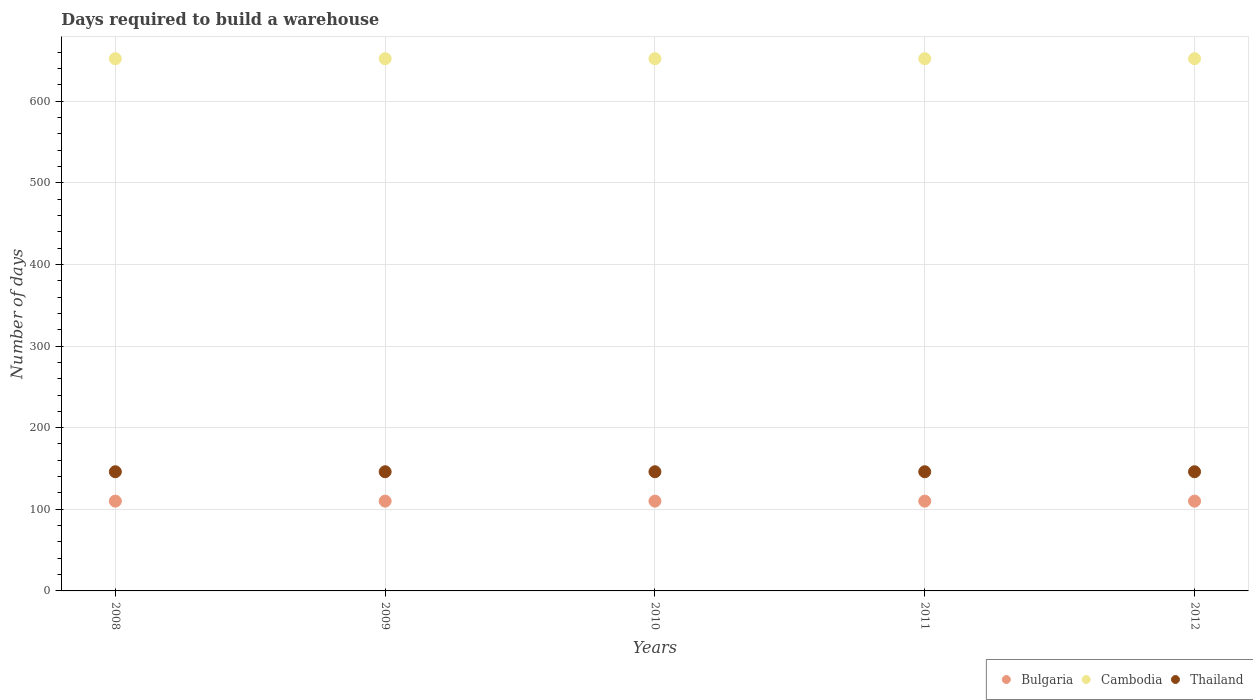What is the days required to build a warehouse in in Thailand in 2009?
Give a very brief answer. 146. Across all years, what is the maximum days required to build a warehouse in in Cambodia?
Your response must be concise. 652. Across all years, what is the minimum days required to build a warehouse in in Cambodia?
Offer a terse response. 652. In which year was the days required to build a warehouse in in Thailand minimum?
Provide a succinct answer. 2008. What is the total days required to build a warehouse in in Thailand in the graph?
Ensure brevity in your answer.  730. What is the difference between the days required to build a warehouse in in Bulgaria in 2011 and the days required to build a warehouse in in Cambodia in 2009?
Provide a short and direct response. -542. What is the average days required to build a warehouse in in Bulgaria per year?
Give a very brief answer. 110. In the year 2012, what is the difference between the days required to build a warehouse in in Bulgaria and days required to build a warehouse in in Thailand?
Provide a succinct answer. -36. In how many years, is the days required to build a warehouse in in Bulgaria greater than 580 days?
Your response must be concise. 0. Does the graph contain any zero values?
Provide a succinct answer. No. What is the title of the graph?
Offer a terse response. Days required to build a warehouse. What is the label or title of the Y-axis?
Provide a succinct answer. Number of days. What is the Number of days in Bulgaria in 2008?
Your answer should be compact. 110. What is the Number of days of Cambodia in 2008?
Your answer should be very brief. 652. What is the Number of days of Thailand in 2008?
Your answer should be compact. 146. What is the Number of days of Bulgaria in 2009?
Your response must be concise. 110. What is the Number of days of Cambodia in 2009?
Keep it short and to the point. 652. What is the Number of days in Thailand in 2009?
Your response must be concise. 146. What is the Number of days of Bulgaria in 2010?
Your answer should be very brief. 110. What is the Number of days of Cambodia in 2010?
Keep it short and to the point. 652. What is the Number of days in Thailand in 2010?
Give a very brief answer. 146. What is the Number of days in Bulgaria in 2011?
Offer a terse response. 110. What is the Number of days in Cambodia in 2011?
Ensure brevity in your answer.  652. What is the Number of days of Thailand in 2011?
Provide a succinct answer. 146. What is the Number of days in Bulgaria in 2012?
Provide a succinct answer. 110. What is the Number of days in Cambodia in 2012?
Give a very brief answer. 652. What is the Number of days of Thailand in 2012?
Give a very brief answer. 146. Across all years, what is the maximum Number of days of Bulgaria?
Provide a succinct answer. 110. Across all years, what is the maximum Number of days in Cambodia?
Your answer should be very brief. 652. Across all years, what is the maximum Number of days of Thailand?
Offer a terse response. 146. Across all years, what is the minimum Number of days of Bulgaria?
Provide a short and direct response. 110. Across all years, what is the minimum Number of days of Cambodia?
Provide a short and direct response. 652. Across all years, what is the minimum Number of days of Thailand?
Provide a short and direct response. 146. What is the total Number of days of Bulgaria in the graph?
Your response must be concise. 550. What is the total Number of days in Cambodia in the graph?
Your answer should be compact. 3260. What is the total Number of days in Thailand in the graph?
Give a very brief answer. 730. What is the difference between the Number of days in Cambodia in 2008 and that in 2009?
Your answer should be very brief. 0. What is the difference between the Number of days in Thailand in 2008 and that in 2009?
Offer a very short reply. 0. What is the difference between the Number of days of Thailand in 2008 and that in 2010?
Provide a succinct answer. 0. What is the difference between the Number of days of Bulgaria in 2008 and that in 2011?
Your response must be concise. 0. What is the difference between the Number of days in Thailand in 2008 and that in 2011?
Provide a short and direct response. 0. What is the difference between the Number of days in Bulgaria in 2008 and that in 2012?
Provide a succinct answer. 0. What is the difference between the Number of days of Cambodia in 2008 and that in 2012?
Provide a short and direct response. 0. What is the difference between the Number of days in Thailand in 2008 and that in 2012?
Ensure brevity in your answer.  0. What is the difference between the Number of days of Bulgaria in 2009 and that in 2010?
Offer a very short reply. 0. What is the difference between the Number of days of Cambodia in 2009 and that in 2010?
Ensure brevity in your answer.  0. What is the difference between the Number of days in Thailand in 2009 and that in 2010?
Offer a terse response. 0. What is the difference between the Number of days in Bulgaria in 2009 and that in 2011?
Make the answer very short. 0. What is the difference between the Number of days in Bulgaria in 2009 and that in 2012?
Make the answer very short. 0. What is the difference between the Number of days in Bulgaria in 2010 and that in 2011?
Give a very brief answer. 0. What is the difference between the Number of days in Thailand in 2010 and that in 2011?
Offer a terse response. 0. What is the difference between the Number of days in Thailand in 2010 and that in 2012?
Keep it short and to the point. 0. What is the difference between the Number of days in Cambodia in 2011 and that in 2012?
Offer a very short reply. 0. What is the difference between the Number of days in Thailand in 2011 and that in 2012?
Offer a very short reply. 0. What is the difference between the Number of days of Bulgaria in 2008 and the Number of days of Cambodia in 2009?
Offer a terse response. -542. What is the difference between the Number of days in Bulgaria in 2008 and the Number of days in Thailand in 2009?
Give a very brief answer. -36. What is the difference between the Number of days of Cambodia in 2008 and the Number of days of Thailand in 2009?
Your response must be concise. 506. What is the difference between the Number of days in Bulgaria in 2008 and the Number of days in Cambodia in 2010?
Keep it short and to the point. -542. What is the difference between the Number of days in Bulgaria in 2008 and the Number of days in Thailand in 2010?
Ensure brevity in your answer.  -36. What is the difference between the Number of days in Cambodia in 2008 and the Number of days in Thailand in 2010?
Your response must be concise. 506. What is the difference between the Number of days of Bulgaria in 2008 and the Number of days of Cambodia in 2011?
Make the answer very short. -542. What is the difference between the Number of days of Bulgaria in 2008 and the Number of days of Thailand in 2011?
Make the answer very short. -36. What is the difference between the Number of days in Cambodia in 2008 and the Number of days in Thailand in 2011?
Your response must be concise. 506. What is the difference between the Number of days in Bulgaria in 2008 and the Number of days in Cambodia in 2012?
Offer a terse response. -542. What is the difference between the Number of days in Bulgaria in 2008 and the Number of days in Thailand in 2012?
Ensure brevity in your answer.  -36. What is the difference between the Number of days of Cambodia in 2008 and the Number of days of Thailand in 2012?
Provide a short and direct response. 506. What is the difference between the Number of days in Bulgaria in 2009 and the Number of days in Cambodia in 2010?
Your answer should be compact. -542. What is the difference between the Number of days of Bulgaria in 2009 and the Number of days of Thailand in 2010?
Ensure brevity in your answer.  -36. What is the difference between the Number of days in Cambodia in 2009 and the Number of days in Thailand in 2010?
Make the answer very short. 506. What is the difference between the Number of days in Bulgaria in 2009 and the Number of days in Cambodia in 2011?
Offer a terse response. -542. What is the difference between the Number of days of Bulgaria in 2009 and the Number of days of Thailand in 2011?
Make the answer very short. -36. What is the difference between the Number of days in Cambodia in 2009 and the Number of days in Thailand in 2011?
Make the answer very short. 506. What is the difference between the Number of days of Bulgaria in 2009 and the Number of days of Cambodia in 2012?
Your answer should be very brief. -542. What is the difference between the Number of days of Bulgaria in 2009 and the Number of days of Thailand in 2012?
Ensure brevity in your answer.  -36. What is the difference between the Number of days of Cambodia in 2009 and the Number of days of Thailand in 2012?
Give a very brief answer. 506. What is the difference between the Number of days in Bulgaria in 2010 and the Number of days in Cambodia in 2011?
Offer a very short reply. -542. What is the difference between the Number of days of Bulgaria in 2010 and the Number of days of Thailand in 2011?
Ensure brevity in your answer.  -36. What is the difference between the Number of days in Cambodia in 2010 and the Number of days in Thailand in 2011?
Provide a short and direct response. 506. What is the difference between the Number of days of Bulgaria in 2010 and the Number of days of Cambodia in 2012?
Give a very brief answer. -542. What is the difference between the Number of days of Bulgaria in 2010 and the Number of days of Thailand in 2012?
Provide a short and direct response. -36. What is the difference between the Number of days in Cambodia in 2010 and the Number of days in Thailand in 2012?
Give a very brief answer. 506. What is the difference between the Number of days of Bulgaria in 2011 and the Number of days of Cambodia in 2012?
Make the answer very short. -542. What is the difference between the Number of days in Bulgaria in 2011 and the Number of days in Thailand in 2012?
Provide a succinct answer. -36. What is the difference between the Number of days in Cambodia in 2011 and the Number of days in Thailand in 2012?
Ensure brevity in your answer.  506. What is the average Number of days in Bulgaria per year?
Offer a very short reply. 110. What is the average Number of days in Cambodia per year?
Make the answer very short. 652. What is the average Number of days in Thailand per year?
Give a very brief answer. 146. In the year 2008, what is the difference between the Number of days in Bulgaria and Number of days in Cambodia?
Ensure brevity in your answer.  -542. In the year 2008, what is the difference between the Number of days in Bulgaria and Number of days in Thailand?
Make the answer very short. -36. In the year 2008, what is the difference between the Number of days of Cambodia and Number of days of Thailand?
Offer a very short reply. 506. In the year 2009, what is the difference between the Number of days of Bulgaria and Number of days of Cambodia?
Your answer should be very brief. -542. In the year 2009, what is the difference between the Number of days in Bulgaria and Number of days in Thailand?
Offer a terse response. -36. In the year 2009, what is the difference between the Number of days in Cambodia and Number of days in Thailand?
Offer a very short reply. 506. In the year 2010, what is the difference between the Number of days in Bulgaria and Number of days in Cambodia?
Ensure brevity in your answer.  -542. In the year 2010, what is the difference between the Number of days in Bulgaria and Number of days in Thailand?
Keep it short and to the point. -36. In the year 2010, what is the difference between the Number of days of Cambodia and Number of days of Thailand?
Give a very brief answer. 506. In the year 2011, what is the difference between the Number of days of Bulgaria and Number of days of Cambodia?
Provide a succinct answer. -542. In the year 2011, what is the difference between the Number of days in Bulgaria and Number of days in Thailand?
Provide a short and direct response. -36. In the year 2011, what is the difference between the Number of days of Cambodia and Number of days of Thailand?
Make the answer very short. 506. In the year 2012, what is the difference between the Number of days in Bulgaria and Number of days in Cambodia?
Your answer should be very brief. -542. In the year 2012, what is the difference between the Number of days of Bulgaria and Number of days of Thailand?
Make the answer very short. -36. In the year 2012, what is the difference between the Number of days in Cambodia and Number of days in Thailand?
Your answer should be compact. 506. What is the ratio of the Number of days of Bulgaria in 2008 to that in 2010?
Make the answer very short. 1. What is the ratio of the Number of days in Cambodia in 2008 to that in 2011?
Make the answer very short. 1. What is the ratio of the Number of days of Cambodia in 2008 to that in 2012?
Ensure brevity in your answer.  1. What is the ratio of the Number of days in Bulgaria in 2009 to that in 2010?
Make the answer very short. 1. What is the ratio of the Number of days of Cambodia in 2009 to that in 2010?
Ensure brevity in your answer.  1. What is the ratio of the Number of days in Cambodia in 2009 to that in 2011?
Keep it short and to the point. 1. What is the ratio of the Number of days in Thailand in 2009 to that in 2011?
Offer a very short reply. 1. What is the ratio of the Number of days of Bulgaria in 2009 to that in 2012?
Ensure brevity in your answer.  1. What is the ratio of the Number of days of Thailand in 2009 to that in 2012?
Offer a very short reply. 1. What is the ratio of the Number of days of Bulgaria in 2010 to that in 2011?
Offer a terse response. 1. What is the ratio of the Number of days in Thailand in 2010 to that in 2011?
Give a very brief answer. 1. What is the ratio of the Number of days in Bulgaria in 2010 to that in 2012?
Offer a terse response. 1. What is the ratio of the Number of days in Thailand in 2010 to that in 2012?
Provide a short and direct response. 1. What is the ratio of the Number of days of Bulgaria in 2011 to that in 2012?
Offer a terse response. 1. What is the difference between the highest and the lowest Number of days of Cambodia?
Your answer should be compact. 0. What is the difference between the highest and the lowest Number of days in Thailand?
Provide a succinct answer. 0. 